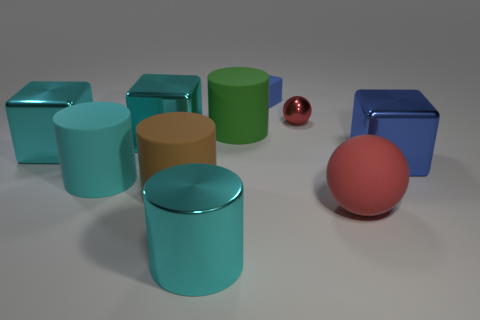How many objects are blue blocks that are right of the tiny sphere or small gray metal things? There are two blue blocks positioned to the right of the tiny red sphere. There are also two small gray metal objects in view, though their positioning in relation to the sphere is not specified. Therefore, the total number of objects that are either blue blocks right of the tiny sphere or small gray metal things is four. 